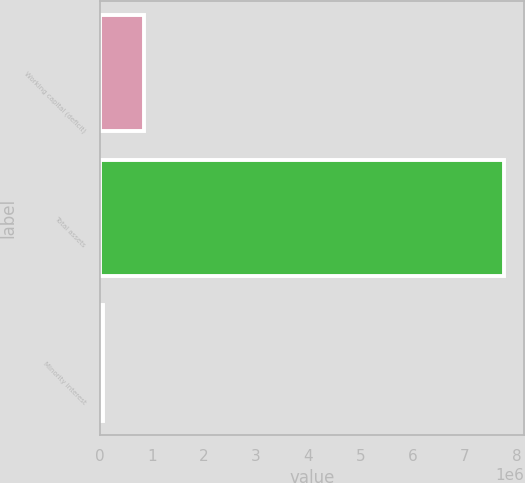<chart> <loc_0><loc_0><loc_500><loc_500><bar_chart><fcel>Working capital (deficit)<fcel>Total assets<fcel>Minority interest<nl><fcel>847981<fcel>7.75689e+06<fcel>71774<nl></chart> 